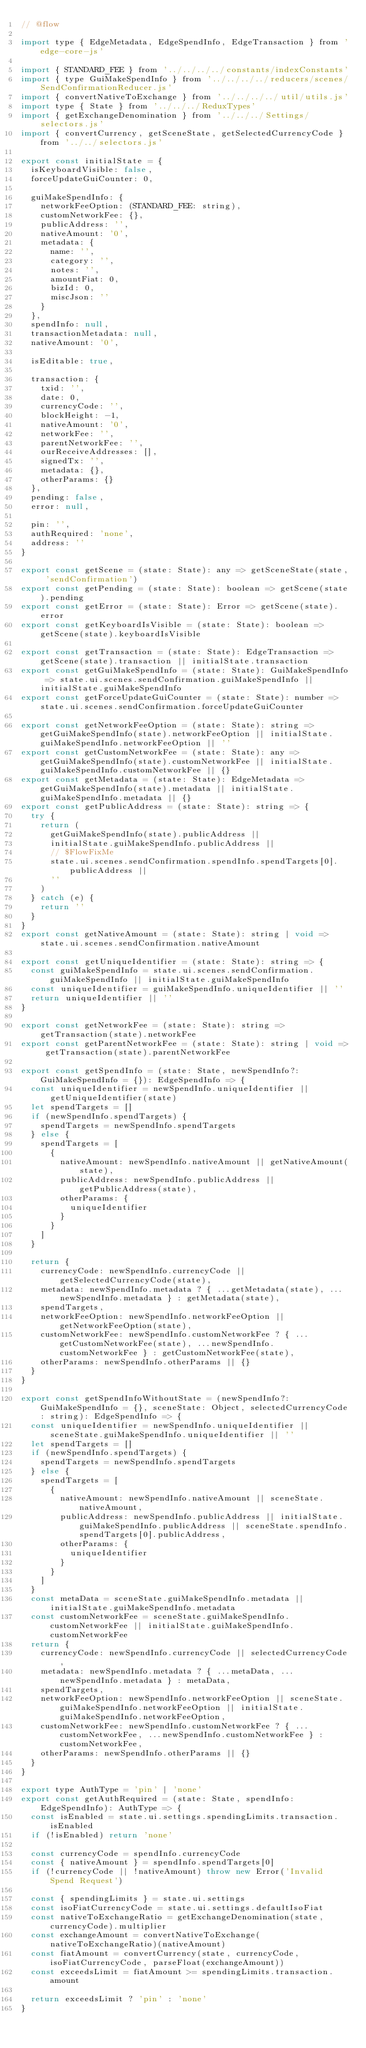<code> <loc_0><loc_0><loc_500><loc_500><_JavaScript_>// @flow

import type { EdgeMetadata, EdgeSpendInfo, EdgeTransaction } from 'edge-core-js'

import { STANDARD_FEE } from '../../../../constants/indexConstants'
import { type GuiMakeSpendInfo } from '../../../../reducers/scenes/SendConfirmationReducer.js'
import { convertNativeToExchange } from '../../../../util/utils.js'
import type { State } from '../../../ReduxTypes'
import { getExchangeDenomination } from '../../../Settings/selectors.js'
import { convertCurrency, getSceneState, getSelectedCurrencyCode } from '../../selectors.js'

export const initialState = {
  isKeyboardVisible: false,
  forceUpdateGuiCounter: 0,

  guiMakeSpendInfo: {
    networkFeeOption: (STANDARD_FEE: string),
    customNetworkFee: {},
    publicAddress: '',
    nativeAmount: '0',
    metadata: {
      name: '',
      category: '',
      notes: '',
      amountFiat: 0,
      bizId: 0,
      miscJson: ''
    }
  },
  spendInfo: null,
  transactionMetadata: null,
  nativeAmount: '0',

  isEditable: true,

  transaction: {
    txid: '',
    date: 0,
    currencyCode: '',
    blockHeight: -1,
    nativeAmount: '0',
    networkFee: '',
    parentNetworkFee: '',
    ourReceiveAddresses: [],
    signedTx: '',
    metadata: {},
    otherParams: {}
  },
  pending: false,
  error: null,

  pin: '',
  authRequired: 'none',
  address: ''
}

export const getScene = (state: State): any => getSceneState(state, 'sendConfirmation')
export const getPending = (state: State): boolean => getScene(state).pending
export const getError = (state: State): Error => getScene(state).error
export const getKeyboardIsVisible = (state: State): boolean => getScene(state).keyboardIsVisible

export const getTransaction = (state: State): EdgeTransaction => getScene(state).transaction || initialState.transaction
export const getGuiMakeSpendInfo = (state: State): GuiMakeSpendInfo => state.ui.scenes.sendConfirmation.guiMakeSpendInfo || initialState.guiMakeSpendInfo
export const getForceUpdateGuiCounter = (state: State): number => state.ui.scenes.sendConfirmation.forceUpdateGuiCounter

export const getNetworkFeeOption = (state: State): string => getGuiMakeSpendInfo(state).networkFeeOption || initialState.guiMakeSpendInfo.networkFeeOption || ''
export const getCustomNetworkFee = (state: State): any => getGuiMakeSpendInfo(state).customNetworkFee || initialState.guiMakeSpendInfo.customNetworkFee || {}
export const getMetadata = (state: State): EdgeMetadata => getGuiMakeSpendInfo(state).metadata || initialState.guiMakeSpendInfo.metadata || {}
export const getPublicAddress = (state: State): string => {
  try {
    return (
      getGuiMakeSpendInfo(state).publicAddress ||
      initialState.guiMakeSpendInfo.publicAddress ||
      // $FlowFixMe
      state.ui.scenes.sendConfirmation.spendInfo.spendTargets[0].publicAddress ||
      ''
    )
  } catch (e) {
    return ''
  }
}
export const getNativeAmount = (state: State): string | void => state.ui.scenes.sendConfirmation.nativeAmount

export const getUniqueIdentifier = (state: State): string => {
  const guiMakeSpendInfo = state.ui.scenes.sendConfirmation.guiMakeSpendInfo || initialState.guiMakeSpendInfo
  const uniqueIdentifier = guiMakeSpendInfo.uniqueIdentifier || ''
  return uniqueIdentifier || ''
}

export const getNetworkFee = (state: State): string => getTransaction(state).networkFee
export const getParentNetworkFee = (state: State): string | void => getTransaction(state).parentNetworkFee

export const getSpendInfo = (state: State, newSpendInfo?: GuiMakeSpendInfo = {}): EdgeSpendInfo => {
  const uniqueIdentifier = newSpendInfo.uniqueIdentifier || getUniqueIdentifier(state)
  let spendTargets = []
  if (newSpendInfo.spendTargets) {
    spendTargets = newSpendInfo.spendTargets
  } else {
    spendTargets = [
      {
        nativeAmount: newSpendInfo.nativeAmount || getNativeAmount(state),
        publicAddress: newSpendInfo.publicAddress || getPublicAddress(state),
        otherParams: {
          uniqueIdentifier
        }
      }
    ]
  }

  return {
    currencyCode: newSpendInfo.currencyCode || getSelectedCurrencyCode(state),
    metadata: newSpendInfo.metadata ? { ...getMetadata(state), ...newSpendInfo.metadata } : getMetadata(state),
    spendTargets,
    networkFeeOption: newSpendInfo.networkFeeOption || getNetworkFeeOption(state),
    customNetworkFee: newSpendInfo.customNetworkFee ? { ...getCustomNetworkFee(state), ...newSpendInfo.customNetworkFee } : getCustomNetworkFee(state),
    otherParams: newSpendInfo.otherParams || {}
  }
}

export const getSpendInfoWithoutState = (newSpendInfo?: GuiMakeSpendInfo = {}, sceneState: Object, selectedCurrencyCode: string): EdgeSpendInfo => {
  const uniqueIdentifier = newSpendInfo.uniqueIdentifier || sceneState.guiMakeSpendInfo.uniqueIdentifier || ''
  let spendTargets = []
  if (newSpendInfo.spendTargets) {
    spendTargets = newSpendInfo.spendTargets
  } else {
    spendTargets = [
      {
        nativeAmount: newSpendInfo.nativeAmount || sceneState.nativeAmount,
        publicAddress: newSpendInfo.publicAddress || initialState.guiMakeSpendInfo.publicAddress || sceneState.spendInfo.spendTargets[0].publicAddress,
        otherParams: {
          uniqueIdentifier
        }
      }
    ]
  }
  const metaData = sceneState.guiMakeSpendInfo.metadata || initialState.guiMakeSpendInfo.metadata
  const customNetworkFee = sceneState.guiMakeSpendInfo.customNetworkFee || initialState.guiMakeSpendInfo.customNetworkFee
  return {
    currencyCode: newSpendInfo.currencyCode || selectedCurrencyCode,
    metadata: newSpendInfo.metadata ? { ...metaData, ...newSpendInfo.metadata } : metaData,
    spendTargets,
    networkFeeOption: newSpendInfo.networkFeeOption || sceneState.guiMakeSpendInfo.networkFeeOption || initialState.guiMakeSpendInfo.networkFeeOption,
    customNetworkFee: newSpendInfo.customNetworkFee ? { ...customNetworkFee, ...newSpendInfo.customNetworkFee } : customNetworkFee,
    otherParams: newSpendInfo.otherParams || {}
  }
}

export type AuthType = 'pin' | 'none'
export const getAuthRequired = (state: State, spendInfo: EdgeSpendInfo): AuthType => {
  const isEnabled = state.ui.settings.spendingLimits.transaction.isEnabled
  if (!isEnabled) return 'none'

  const currencyCode = spendInfo.currencyCode
  const { nativeAmount } = spendInfo.spendTargets[0]
  if (!currencyCode || !nativeAmount) throw new Error('Invalid Spend Request')

  const { spendingLimits } = state.ui.settings
  const isoFiatCurrencyCode = state.ui.settings.defaultIsoFiat
  const nativeToExchangeRatio = getExchangeDenomination(state, currencyCode).multiplier
  const exchangeAmount = convertNativeToExchange(nativeToExchangeRatio)(nativeAmount)
  const fiatAmount = convertCurrency(state, currencyCode, isoFiatCurrencyCode, parseFloat(exchangeAmount))
  const exceedsLimit = fiatAmount >= spendingLimits.transaction.amount

  return exceedsLimit ? 'pin' : 'none'
}
</code> 